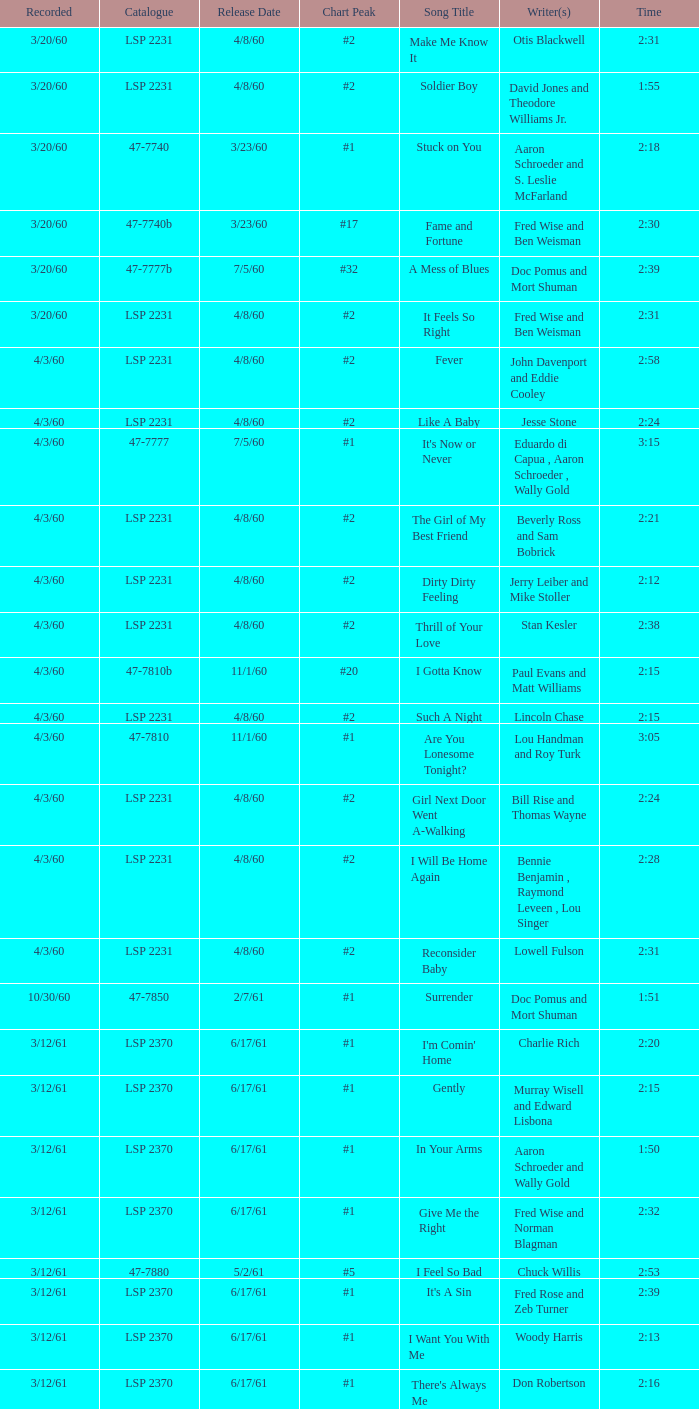What catalogue is the song It's Now or Never? 47-7777. 